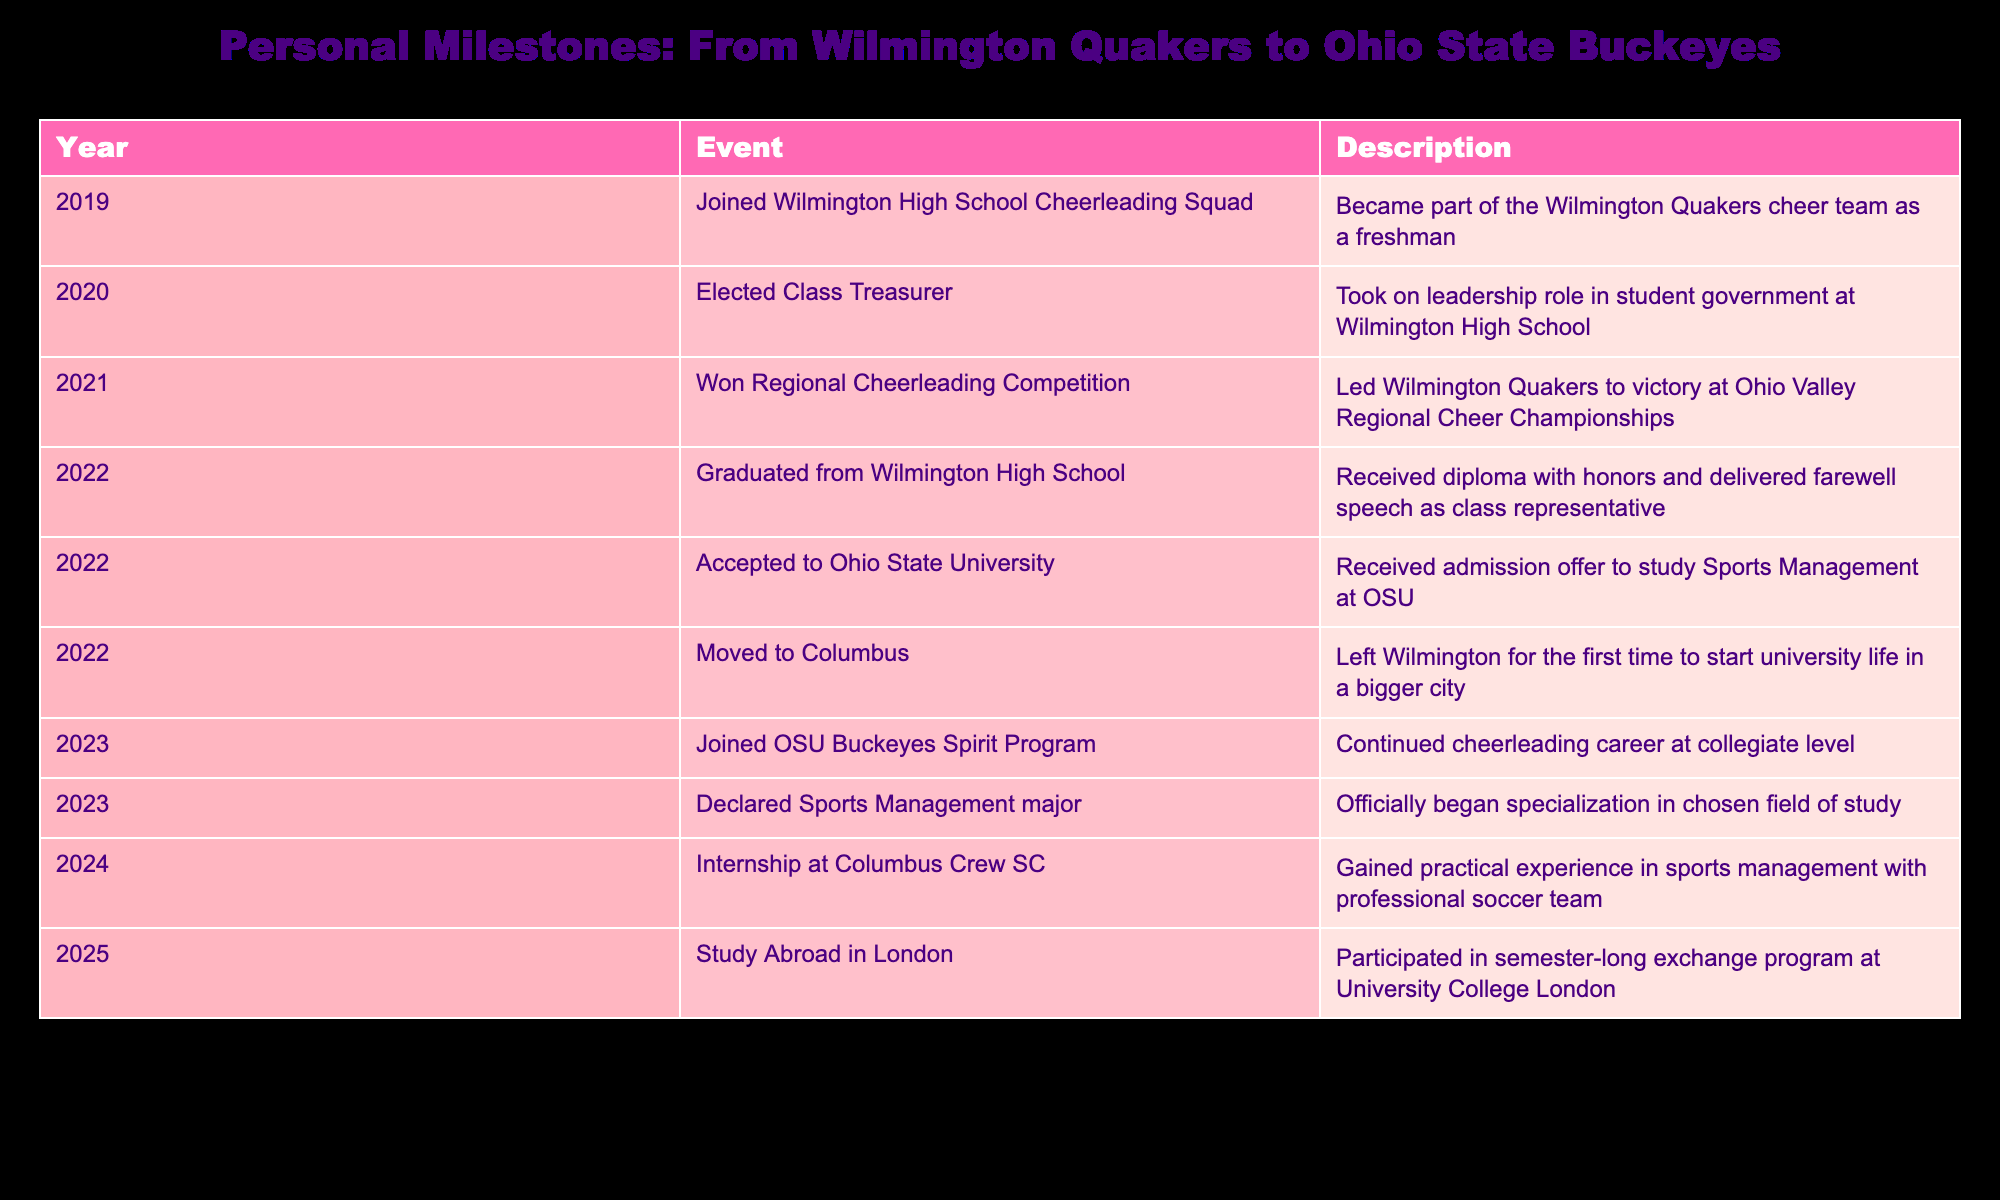What year did you graduate from Wilmington High School? The table indicates the event "Graduated from Wilmington High School" occurred in the year 2022. Therefore, this is the year of graduation.
Answer: 2022 How many events occurred in the year 2022? Reviewing the table, there are three events listed for 2022: "Graduated from Wilmington High School," "Accepted to Ohio State University," and "Moved to Columbus." Therefore, there are three events.
Answer: 3 Did you join the OSU Buckeyes Spirit Program? Yes, according to the table, the event "Joined OSU Buckeyes Spirit Program" occurred in 2023, confirming membership in the program.
Answer: Yes What is the difference in years between winning the Regional Cheerleading Competition and graduating high school? The "Won Regional Cheerleading Competition" event is listed for 2021, and "Graduated from Wilmington High School" is in 2022. The difference between these years is 2022 - 2021 = 1 year.
Answer: 1 year In what year did you move to Columbus? The table states that the event "Moved to Columbus" occurred in 2022, which is the year of the move.
Answer: 2022 How many total years passed from joining the Wilmington High School Cheerleading Squad to starting an internship at Columbus Crew SC? The timeline indicates joining the cheerleading squad in 2019 and starting the internship in 2024. The total time from 2019 to 2024 is 2024 - 2019 = 5 years.
Answer: 5 years What was your leadership role while at Wilmington High School? The table shows the event "Elected Class Treasurer" as occurring in 2020, indicating that this was the leadership role taken on.
Answer: Class Treasurer Did you study abroad in London during university? Yes, according to the table, there is an event labeled "Study Abroad in London" in 2025, confirming participation in an exchange program.
Answer: Yes How many events related to cheerleading are listed in the table? The table records three cheerleading-related events: "Joined Wilmington High School Cheerleading Squad," "Won Regional Cheerleading Competition," and "Joined OSU Buckeyes Spirit Program." Therefore, the total is three events.
Answer: 3 